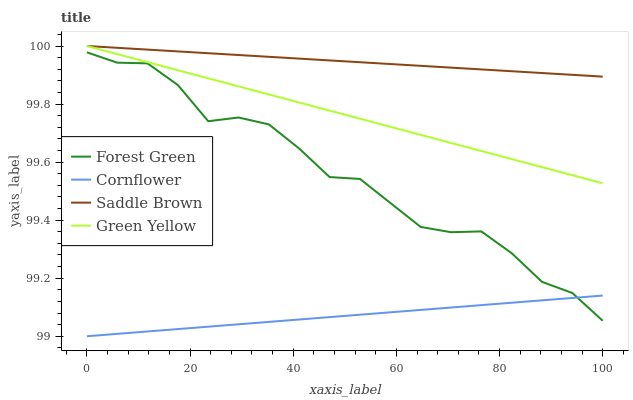Does Cornflower have the minimum area under the curve?
Answer yes or no. Yes. Does Saddle Brown have the maximum area under the curve?
Answer yes or no. Yes. Does Forest Green have the minimum area under the curve?
Answer yes or no. No. Does Forest Green have the maximum area under the curve?
Answer yes or no. No. Is Saddle Brown the smoothest?
Answer yes or no. Yes. Is Forest Green the roughest?
Answer yes or no. Yes. Is Green Yellow the smoothest?
Answer yes or no. No. Is Green Yellow the roughest?
Answer yes or no. No. Does Cornflower have the lowest value?
Answer yes or no. Yes. Does Forest Green have the lowest value?
Answer yes or no. No. Does Saddle Brown have the highest value?
Answer yes or no. Yes. Does Forest Green have the highest value?
Answer yes or no. No. Is Cornflower less than Green Yellow?
Answer yes or no. Yes. Is Saddle Brown greater than Forest Green?
Answer yes or no. Yes. Does Saddle Brown intersect Green Yellow?
Answer yes or no. Yes. Is Saddle Brown less than Green Yellow?
Answer yes or no. No. Is Saddle Brown greater than Green Yellow?
Answer yes or no. No. Does Cornflower intersect Green Yellow?
Answer yes or no. No. 